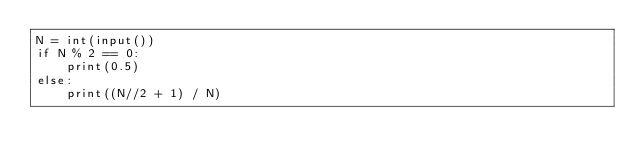Convert code to text. <code><loc_0><loc_0><loc_500><loc_500><_Python_>N = int(input())
if N % 2 == 0:
    print(0.5)
else:
    print((N//2 + 1) / N)</code> 